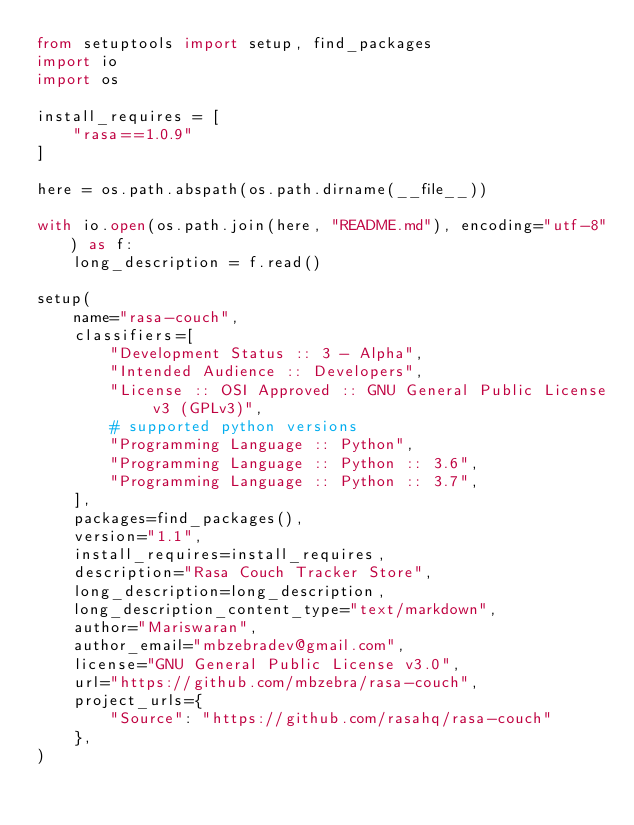Convert code to text. <code><loc_0><loc_0><loc_500><loc_500><_Python_>from setuptools import setup, find_packages
import io
import os

install_requires = [
    "rasa==1.0.9"
]

here = os.path.abspath(os.path.dirname(__file__))

with io.open(os.path.join(here, "README.md"), encoding="utf-8") as f:
    long_description = f.read()

setup(
    name="rasa-couch",
    classifiers=[
        "Development Status :: 3 - Alpha",
        "Intended Audience :: Developers",
        "License :: OSI Approved :: GNU General Public License v3 (GPLv3)",
        # supported python versions
        "Programming Language :: Python",
        "Programming Language :: Python :: 3.6",
        "Programming Language :: Python :: 3.7",
    ],
    packages=find_packages(),
    version="1.1",
    install_requires=install_requires,
    description="Rasa Couch Tracker Store",
    long_description=long_description,
    long_description_content_type="text/markdown",
    author="Mariswaran",
    author_email="mbzebradev@gmail.com",
    license="GNU General Public License v3.0",
    url="https://github.com/mbzebra/rasa-couch",
    project_urls={
        "Source": "https://github.com/rasahq/rasa-couch"
    },
)
</code> 